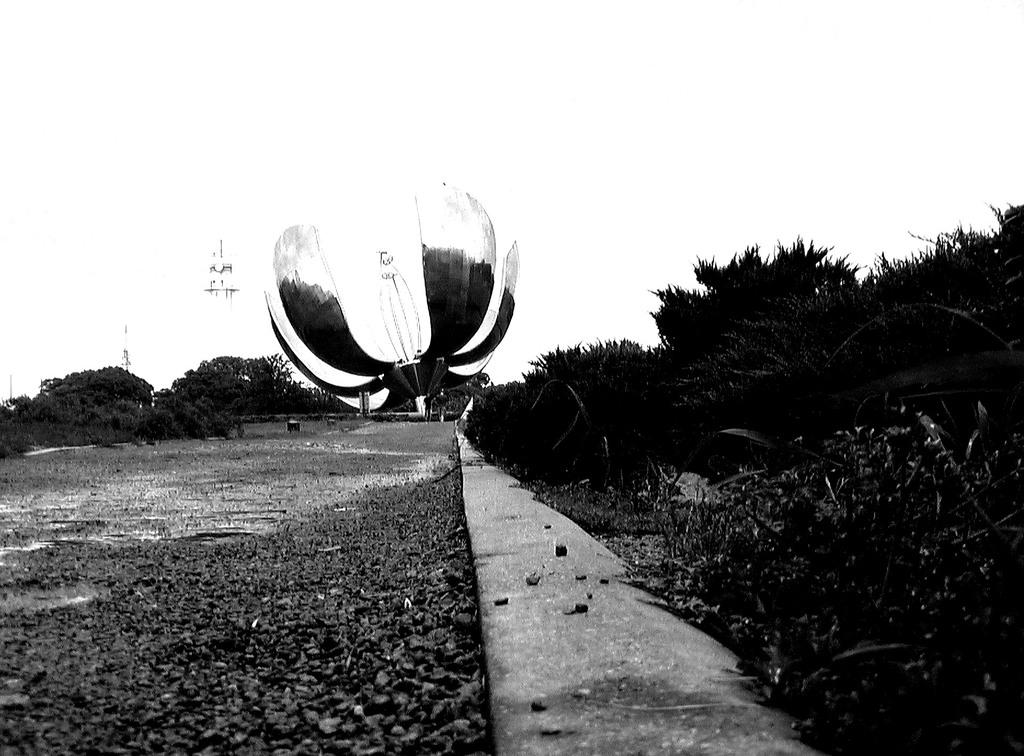What type of surface can be seen in the image? There is a road in the image. What type of vegetation is present in the image? There is grass in the image. Can you describe the unspecified object in the image? Unfortunately, the facts provided do not give any details about the unspecified object. What is the color scheme of the image? The image is black and white in color. How many geese are flying over the road in the image? There are no geese present in the image; it is a black and white image with a road and grass. What type of pollution can be seen in the image? There is no pollution visible in the image, as it is a black and white image with a road, grass, and an unspecified object. 